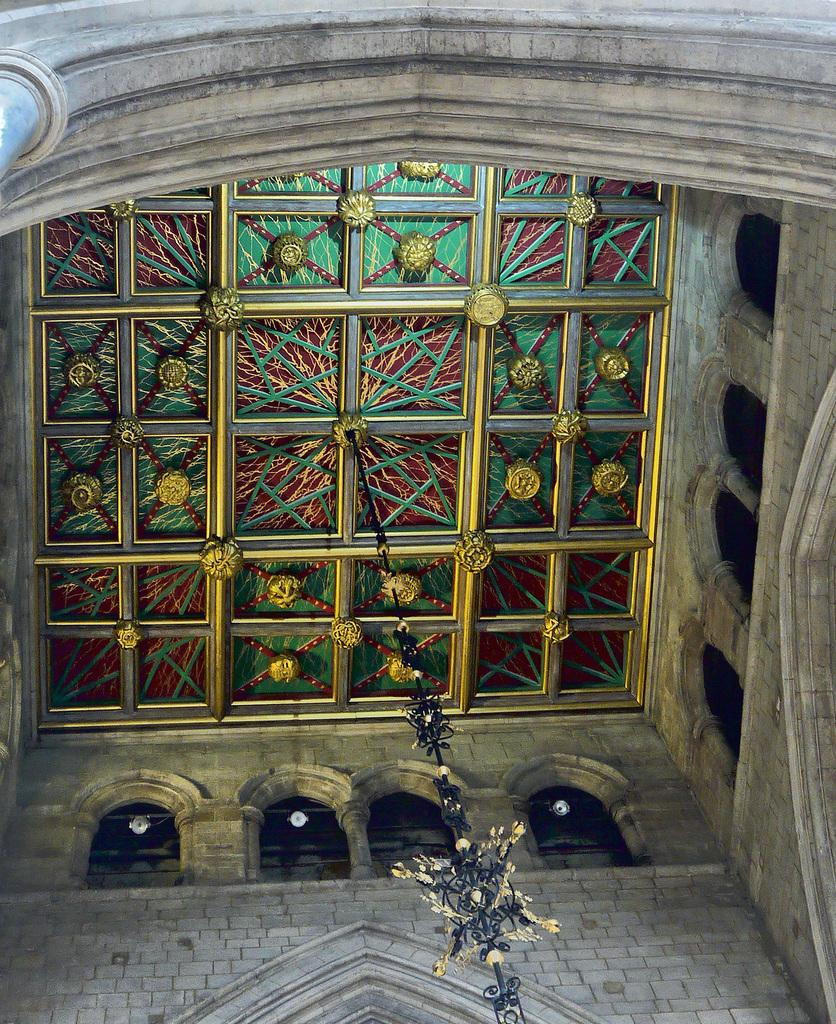What is the main subject in the center of the image? There is a roof in the center of the image. What type of throat-soothing remedy can be seen in the image? There is no throat-soothing remedy present in the image; it only features a roof. Can you describe the flame coming from the roof in the image? There is no flame present in the image; it only features a roof. 